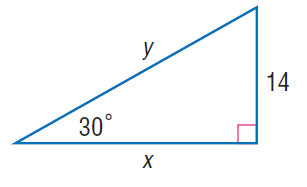Answer the mathemtical geometry problem and directly provide the correct option letter.
Question: Find x.
Choices: A: 8 \sqrt { 3 } B: 10 \sqrt { 3 } C: 12 \sqrt { 3 } D: 14 \sqrt { 3 } D 